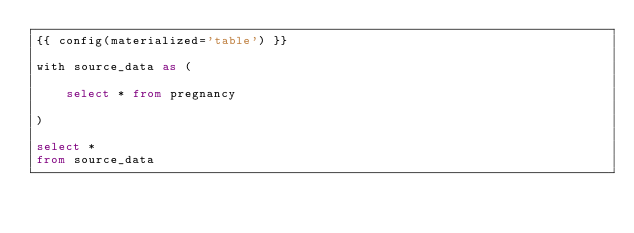<code> <loc_0><loc_0><loc_500><loc_500><_SQL_>{{ config(materialized='table') }}

with source_data as (

    select * from pregnancy

)

select *
from source_data</code> 